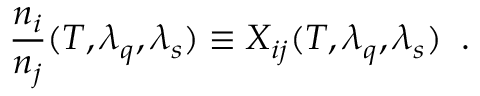Convert formula to latex. <formula><loc_0><loc_0><loc_500><loc_500>\frac { n _ { i } } { n _ { j } } ( T , \lambda _ { q } , \lambda _ { s } ) \equiv X _ { i j } ( T , \lambda _ { q } , \lambda _ { s } ) \, .</formula> 